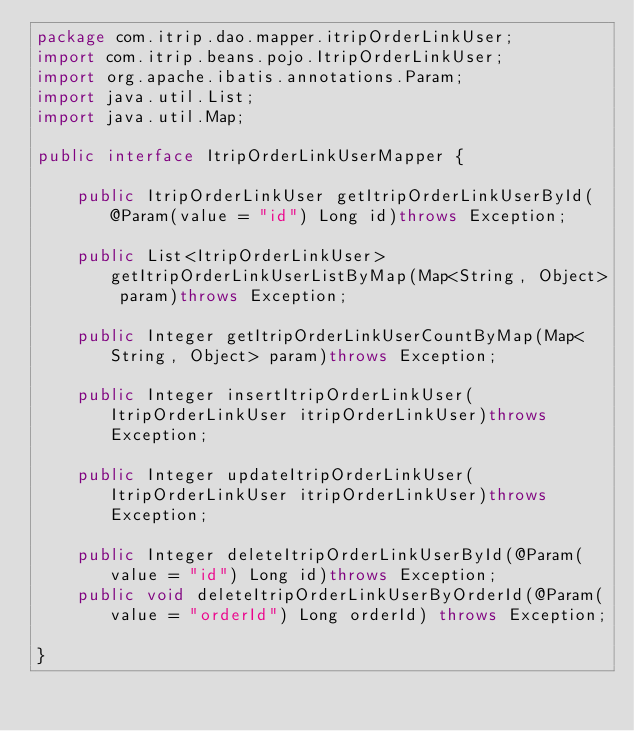Convert code to text. <code><loc_0><loc_0><loc_500><loc_500><_Java_>package com.itrip.dao.mapper.itripOrderLinkUser;
import com.itrip.beans.pojo.ItripOrderLinkUser;
import org.apache.ibatis.annotations.Param;
import java.util.List;
import java.util.Map;

public interface ItripOrderLinkUserMapper {

	public ItripOrderLinkUser getItripOrderLinkUserById(@Param(value = "id") Long id)throws Exception;

	public List<ItripOrderLinkUser>	getItripOrderLinkUserListByMap(Map<String, Object> param)throws Exception;

	public Integer getItripOrderLinkUserCountByMap(Map<String, Object> param)throws Exception;

	public Integer insertItripOrderLinkUser(ItripOrderLinkUser itripOrderLinkUser)throws Exception;

	public Integer updateItripOrderLinkUser(ItripOrderLinkUser itripOrderLinkUser)throws Exception;

	public Integer deleteItripOrderLinkUserById(@Param(value = "id") Long id)throws Exception;
	public void deleteItripOrderLinkUserByOrderId(@Param(value = "orderId") Long orderId) throws Exception;

}
</code> 